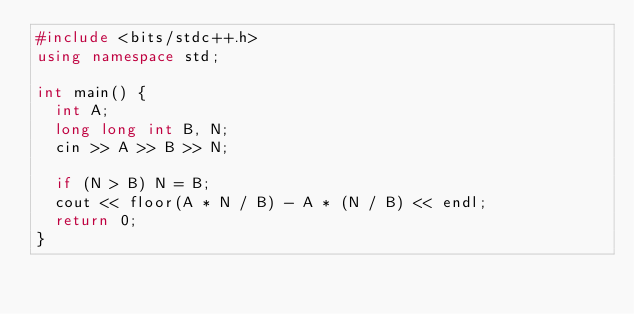Convert code to text. <code><loc_0><loc_0><loc_500><loc_500><_C++_>#include <bits/stdc++.h>
using namespace std;

int main() {
	int A;
	long long int B, N;
	cin >> A >> B >> N;

	if (N > B) N = B;
	cout << floor(A * N / B) - A * (N / B) << endl;
	return 0;
}</code> 